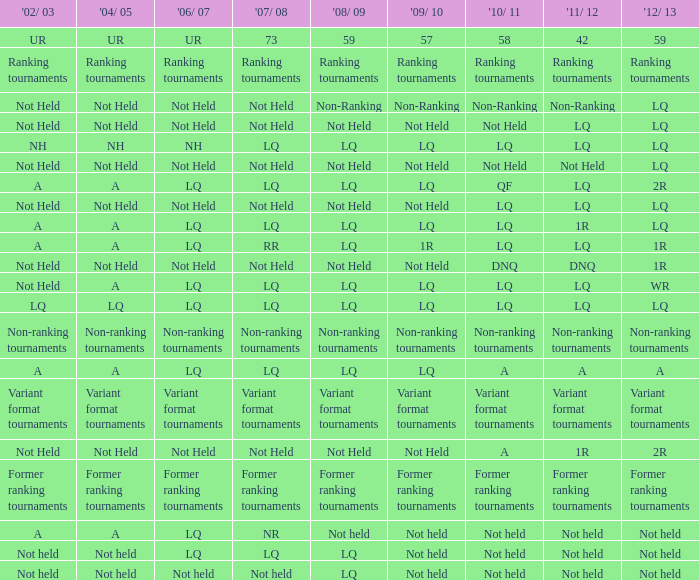Name the 2009/10 with 2011/12 of a LQ. 